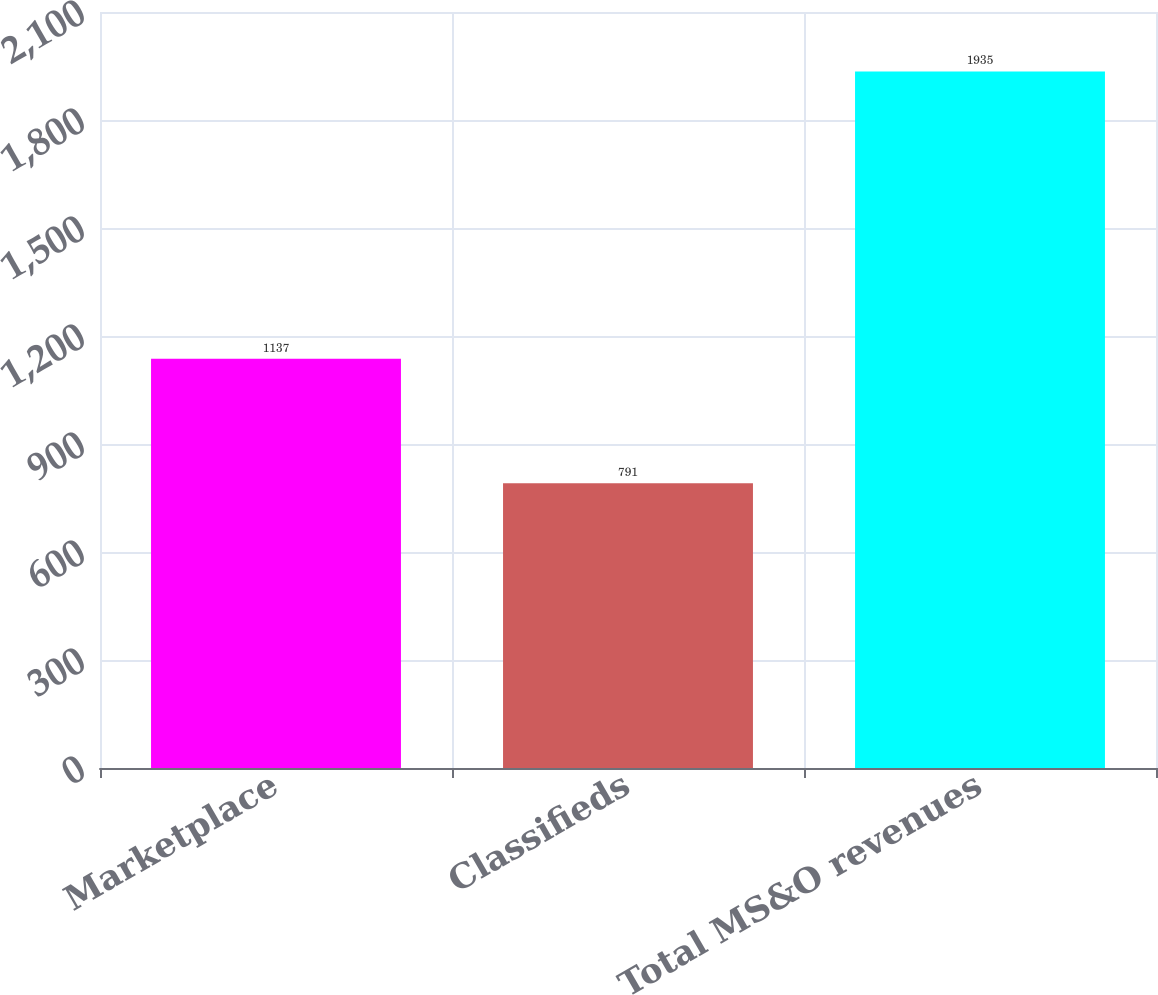<chart> <loc_0><loc_0><loc_500><loc_500><bar_chart><fcel>Marketplace<fcel>Classifieds<fcel>Total MS&O revenues<nl><fcel>1137<fcel>791<fcel>1935<nl></chart> 